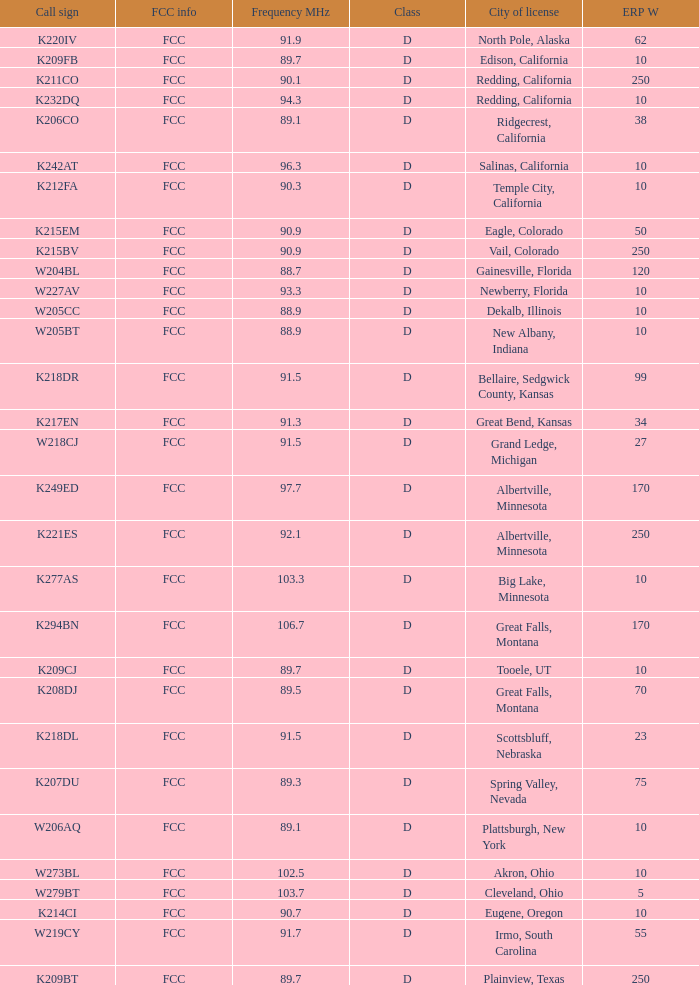What is the call sign of the translator with an ERP W greater than 38 and a city license from Great Falls, Montana? K294BN, K208DJ. 